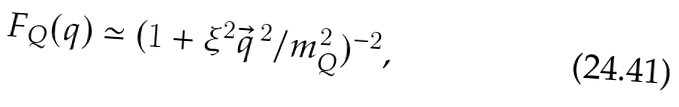<formula> <loc_0><loc_0><loc_500><loc_500>F _ { Q } ( q ) \simeq ( 1 + \xi ^ { 2 } { \vec { q } } ^ { \, 2 } / m _ { Q } ^ { 2 } ) ^ { - 2 } ,</formula> 